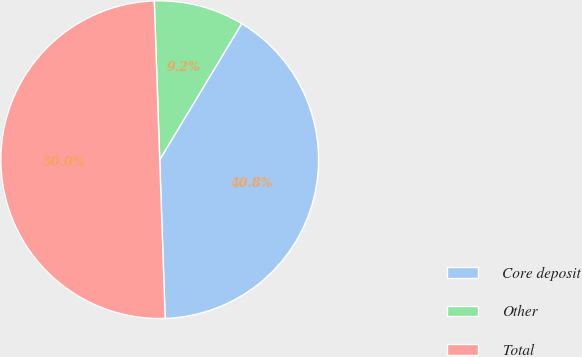<chart> <loc_0><loc_0><loc_500><loc_500><pie_chart><fcel>Core deposit<fcel>Other<fcel>Total<nl><fcel>40.82%<fcel>9.18%<fcel>50.0%<nl></chart> 